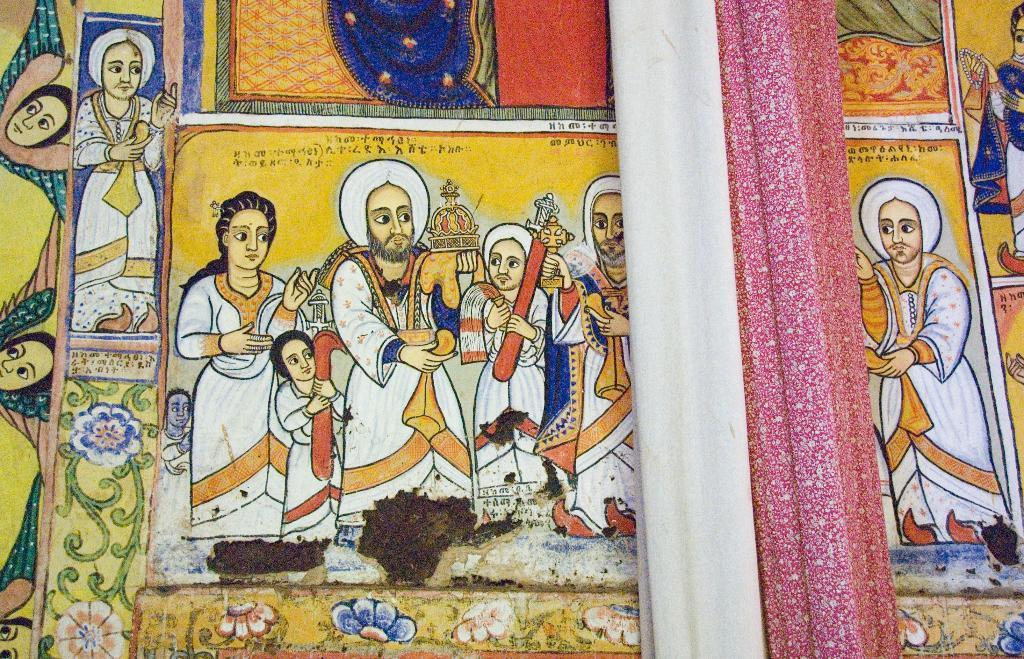What is on the wall in the image? There is a painting on the wall. Is there anything covering or partially obscuring the painting? Yes, there is a curtain hanging in front of the painting. How many people are driving in the image? There is no reference to driving or any vehicles in the image, so it's not possible to determine the number of people driving. 